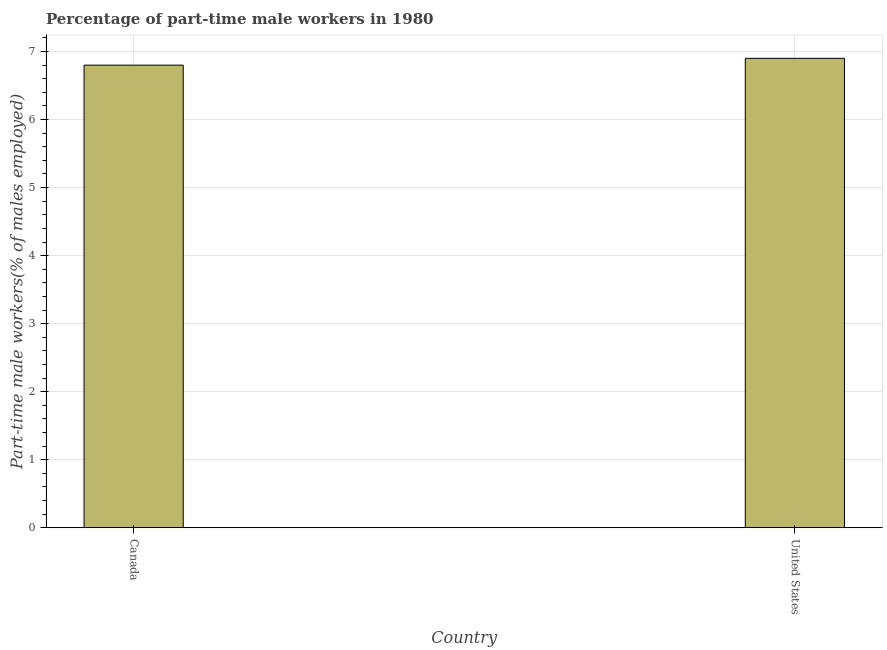Does the graph contain grids?
Your answer should be compact. Yes. What is the title of the graph?
Provide a succinct answer. Percentage of part-time male workers in 1980. What is the label or title of the Y-axis?
Ensure brevity in your answer.  Part-time male workers(% of males employed). What is the percentage of part-time male workers in Canada?
Your answer should be very brief. 6.8. Across all countries, what is the maximum percentage of part-time male workers?
Your response must be concise. 6.9. Across all countries, what is the minimum percentage of part-time male workers?
Provide a succinct answer. 6.8. In which country was the percentage of part-time male workers maximum?
Your answer should be compact. United States. In which country was the percentage of part-time male workers minimum?
Offer a very short reply. Canada. What is the sum of the percentage of part-time male workers?
Your answer should be compact. 13.7. What is the difference between the percentage of part-time male workers in Canada and United States?
Keep it short and to the point. -0.1. What is the average percentage of part-time male workers per country?
Keep it short and to the point. 6.85. What is the median percentage of part-time male workers?
Your response must be concise. 6.85. In how many countries, is the percentage of part-time male workers greater than 2.6 %?
Offer a terse response. 2. What is the ratio of the percentage of part-time male workers in Canada to that in United States?
Provide a succinct answer. 0.99. Is the percentage of part-time male workers in Canada less than that in United States?
Your answer should be very brief. Yes. Are all the bars in the graph horizontal?
Make the answer very short. No. How many countries are there in the graph?
Ensure brevity in your answer.  2. What is the Part-time male workers(% of males employed) of Canada?
Give a very brief answer. 6.8. What is the Part-time male workers(% of males employed) of United States?
Provide a short and direct response. 6.9. What is the ratio of the Part-time male workers(% of males employed) in Canada to that in United States?
Keep it short and to the point. 0.99. 